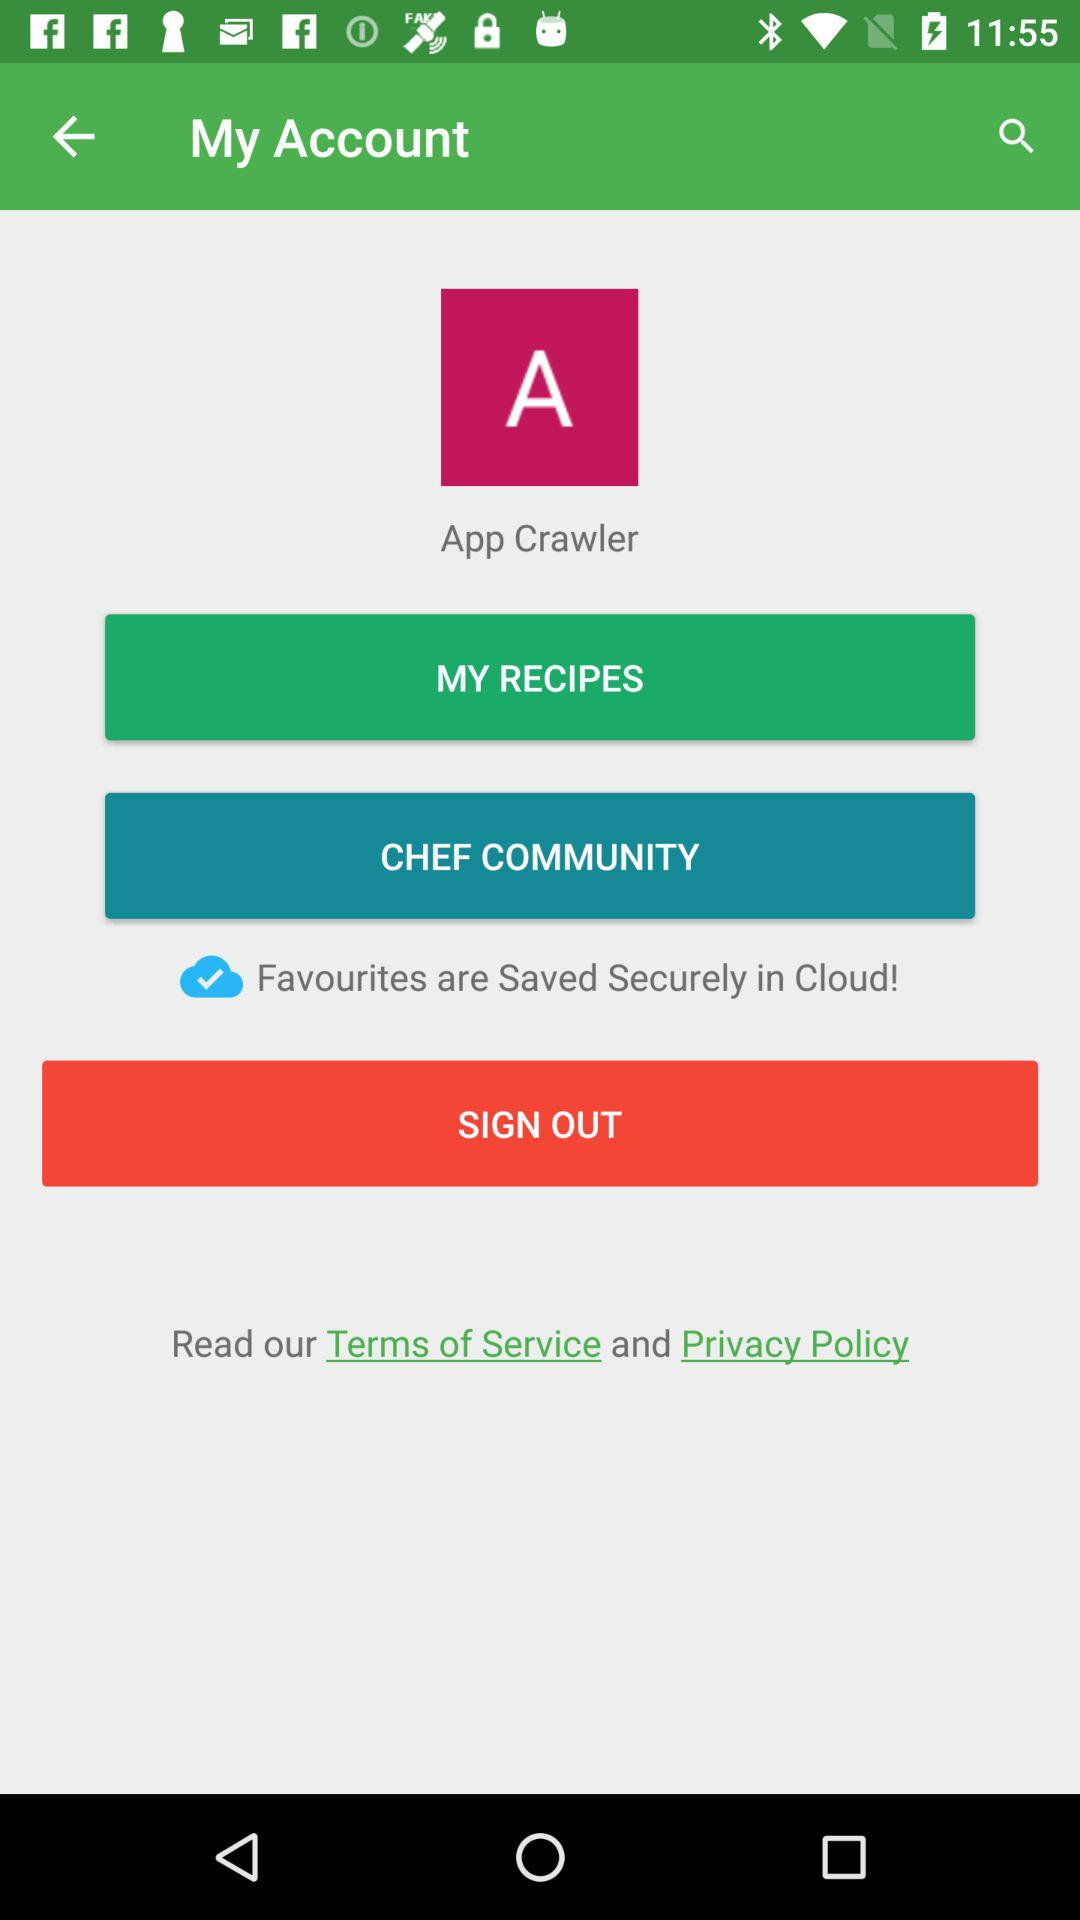What is the name of the user? The name of the user is App Crawler. 